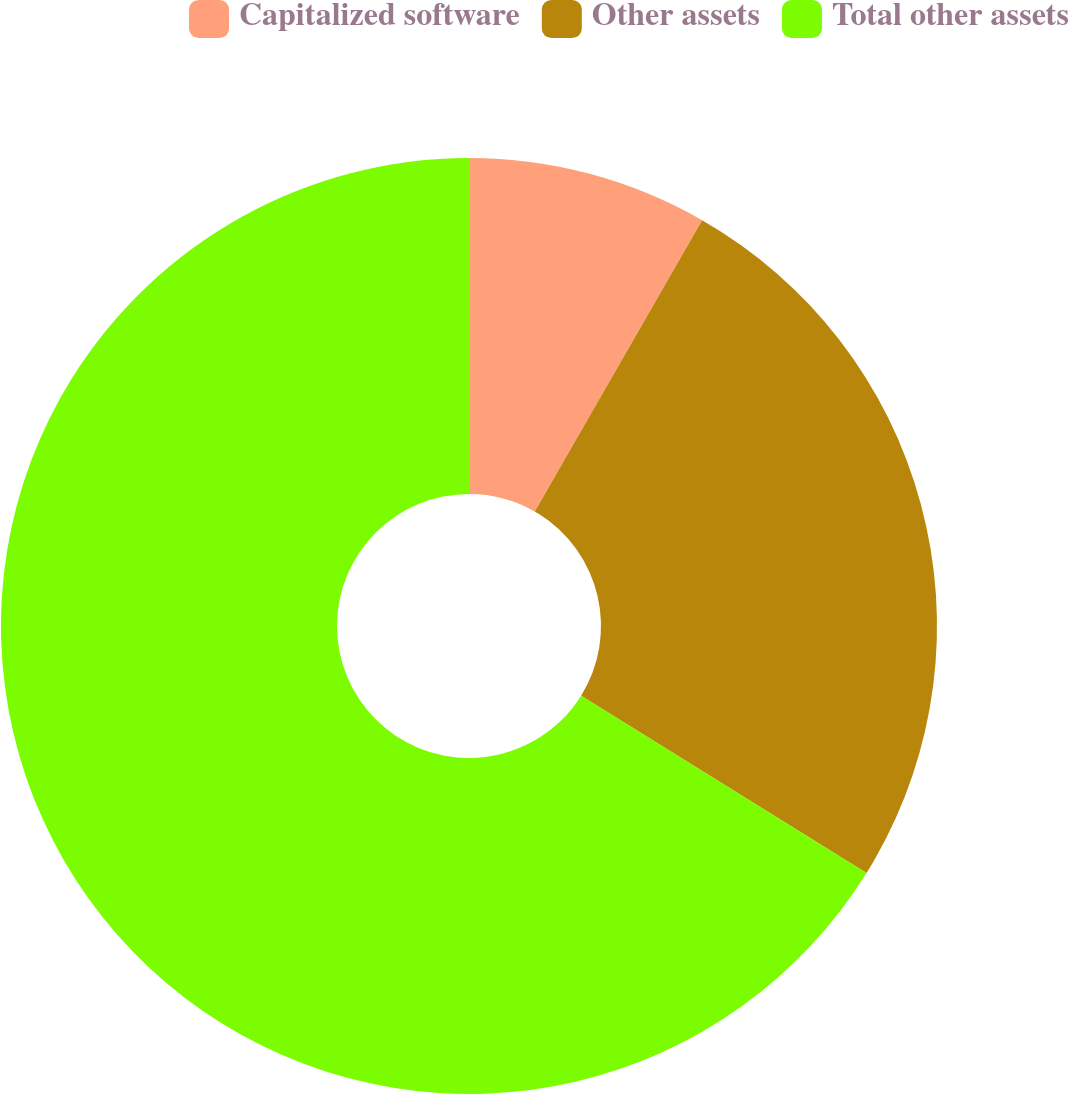Convert chart. <chart><loc_0><loc_0><loc_500><loc_500><pie_chart><fcel>Capitalized software<fcel>Other assets<fcel>Total other assets<nl><fcel>8.3%<fcel>25.55%<fcel>66.16%<nl></chart> 